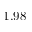Convert formula to latex. <formula><loc_0><loc_0><loc_500><loc_500>1 . 9 8</formula> 